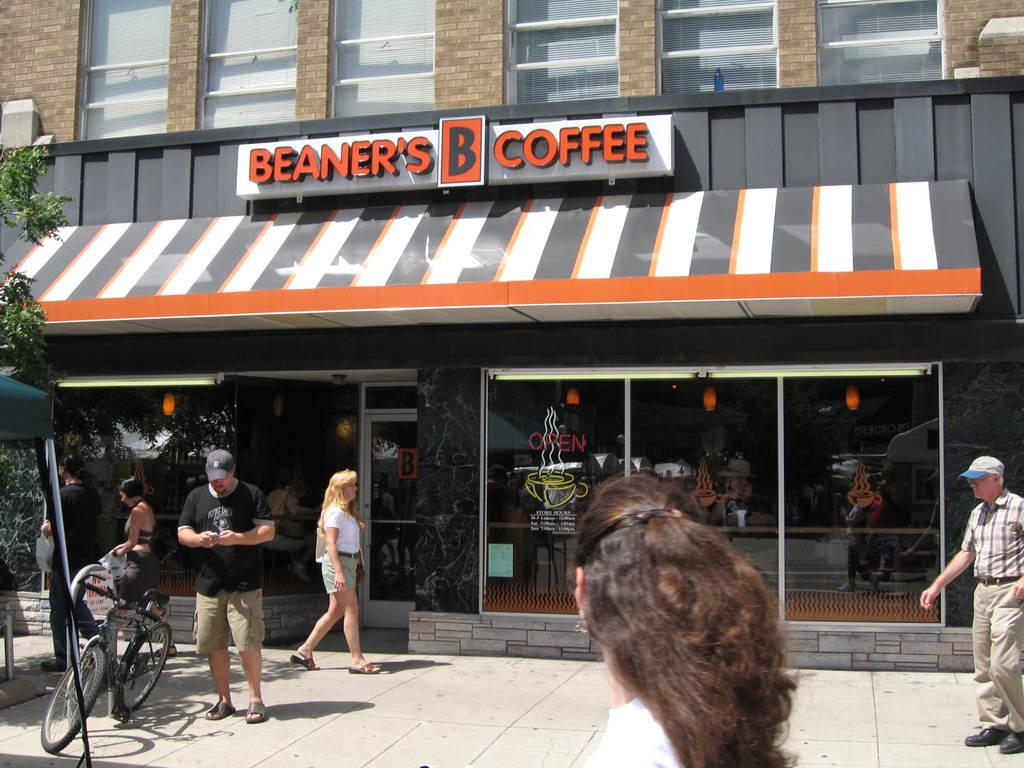<image>
Create a compact narrative representing the image presented. People walk on a street outside a Beaner's Coffee. 